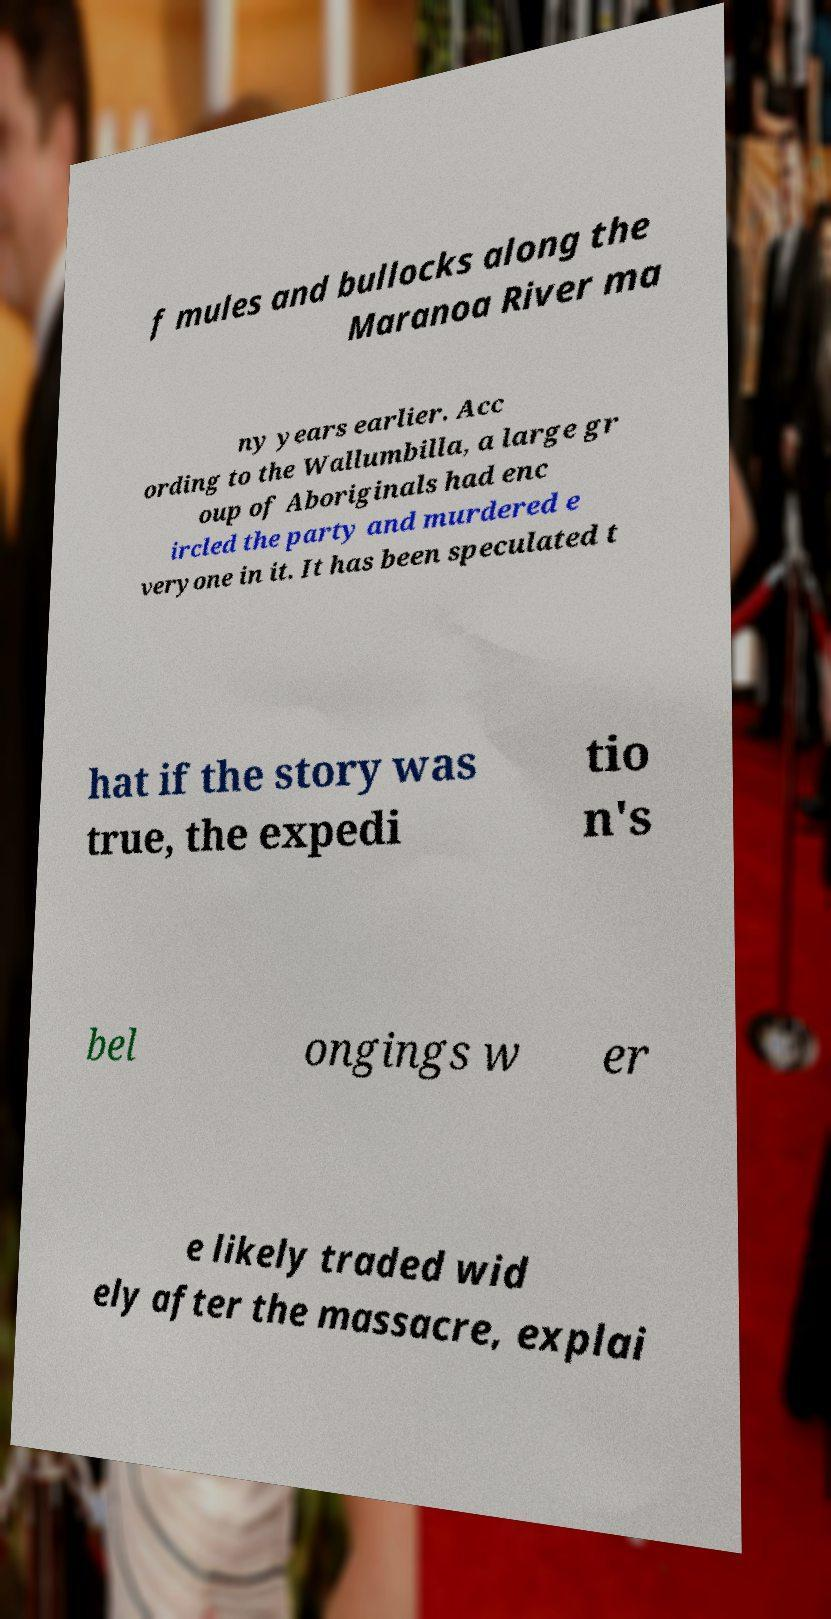There's text embedded in this image that I need extracted. Can you transcribe it verbatim? f mules and bullocks along the Maranoa River ma ny years earlier. Acc ording to the Wallumbilla, a large gr oup of Aboriginals had enc ircled the party and murdered e veryone in it. It has been speculated t hat if the story was true, the expedi tio n's bel ongings w er e likely traded wid ely after the massacre, explai 